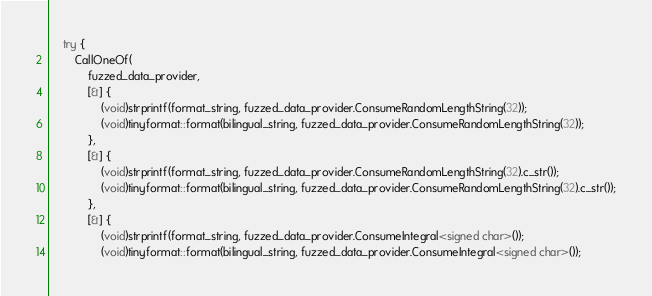<code> <loc_0><loc_0><loc_500><loc_500><_C++_>
    try {
        CallOneOf(
            fuzzed_data_provider,
            [&] {
                (void)strprintf(format_string, fuzzed_data_provider.ConsumeRandomLengthString(32));
                (void)tinyformat::format(bilingual_string, fuzzed_data_provider.ConsumeRandomLengthString(32));
            },
            [&] {
                (void)strprintf(format_string, fuzzed_data_provider.ConsumeRandomLengthString(32).c_str());
                (void)tinyformat::format(bilingual_string, fuzzed_data_provider.ConsumeRandomLengthString(32).c_str());
            },
            [&] {
                (void)strprintf(format_string, fuzzed_data_provider.ConsumeIntegral<signed char>());
                (void)tinyformat::format(bilingual_string, fuzzed_data_provider.ConsumeIntegral<signed char>());</code> 